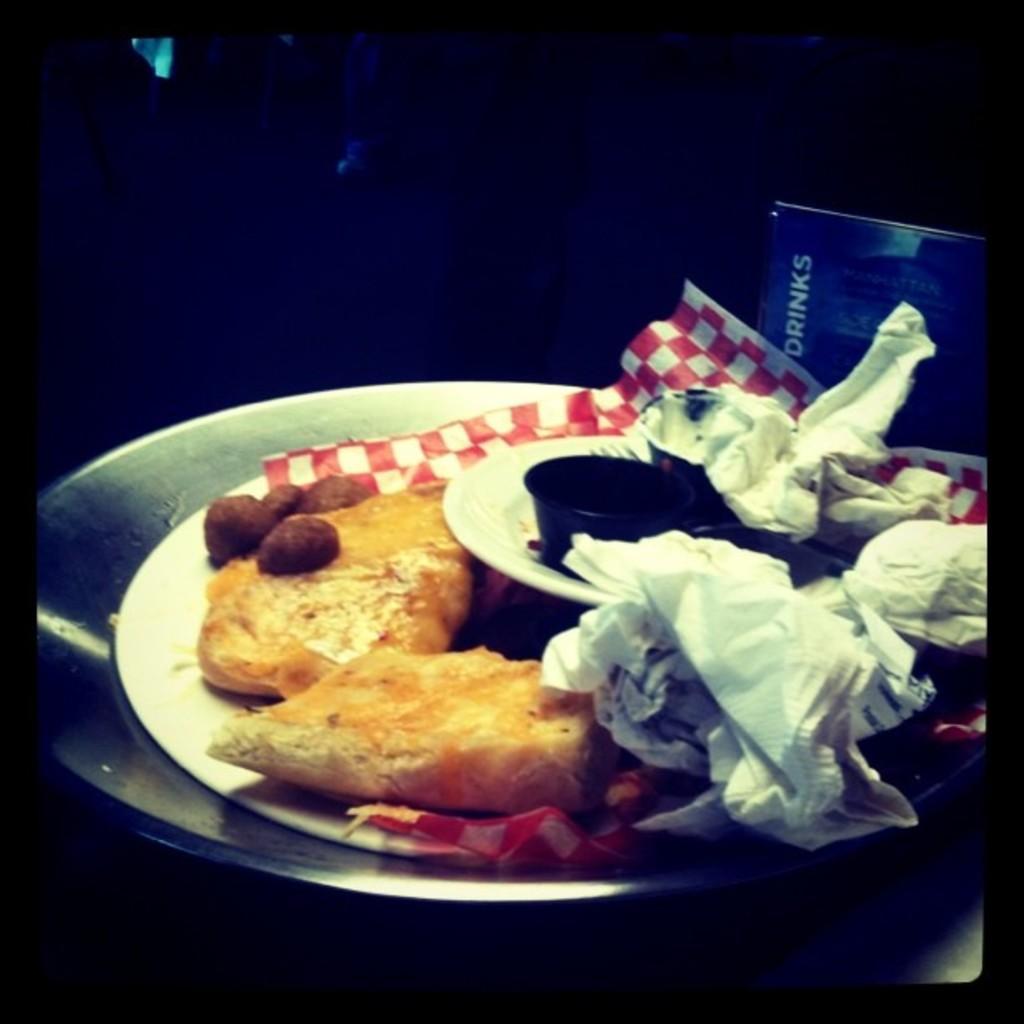Describe this image in one or two sentences. In this image we can see the group of plates and bowl containing food and papers are placed on the surface. In the background, we can see a board with some text. 